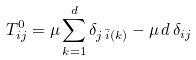<formula> <loc_0><loc_0><loc_500><loc_500>T ^ { 0 } _ { i j } = \mu \sum _ { k = 1 } ^ { d } \delta _ { j \, \bar { i } ( k ) } - \mu \, d \, \delta _ { i j }</formula> 